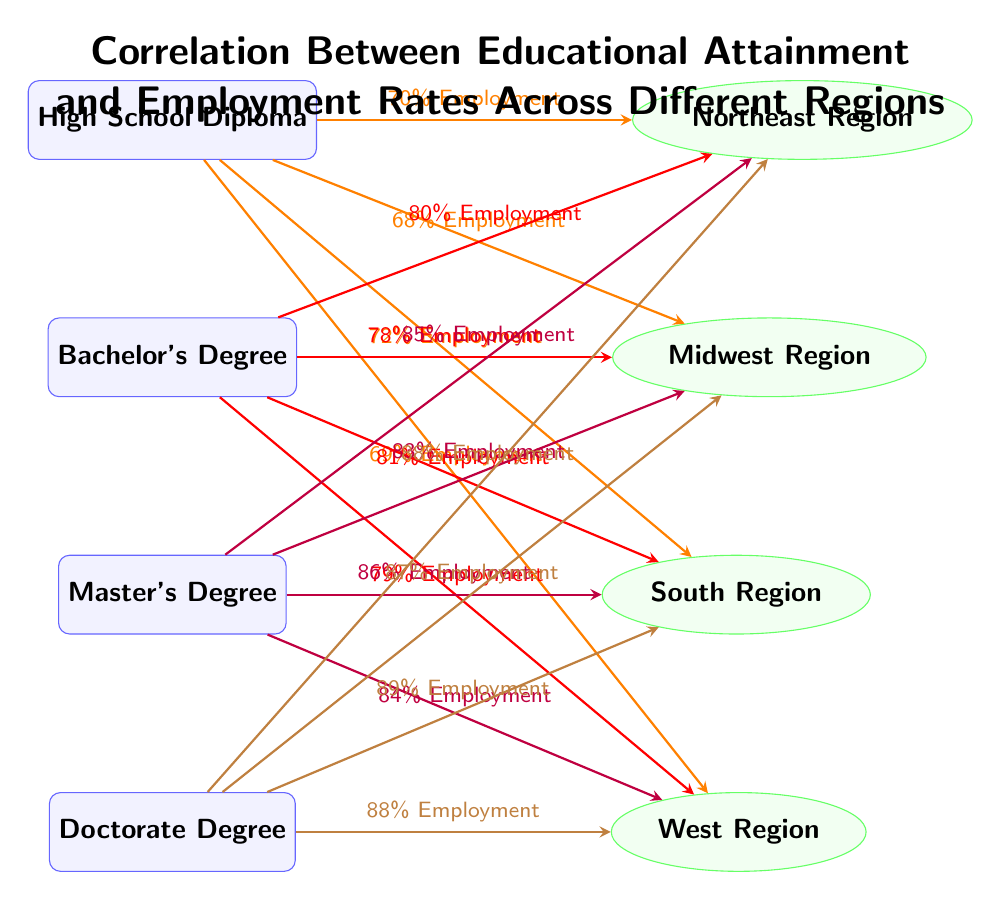What is the employment rate for Bachelor's Degree holders in the South Region? The diagram shows a connection between Bachelor's Degree and the South Region with an associated employment rate of 81%.
Answer: 81% How many education levels are represented in the diagram? The diagram includes four educational levels: High School Diploma, Bachelor's Degree, Master's Degree, and Doctorate Degree. Therefore, there are four education nodes in total.
Answer: 4 What is the employment rate for High School Diploma holders in the Midwest Region? The connection from the High School Diploma node to the Midwest Region indicates an employment rate of 68%.
Answer: 68% Which educational attainment has the highest employment rate in the Northeast Region? By comparing the employment rates for all education levels in the Northeast Region, the Doctorate Degree shows the highest employment rate at 88%.
Answer: Doctorate Degree How does employment rate change from High School Diploma to Master's Degree in the West Region? The employment rate for High School Diploma holders in the West Region is 69%, while for Master's Degree holders, it is 84%. Thus, there is an increase of 15%.
Answer: Increase by 15% Which region shows the highest employment rate for Master’s Degree holders? The diagram indicates that the employment rate for Master’s Degree holders is 85% in the Northeast Region, which is the highest compared to other regions.
Answer: Northeast Region What is the employment rate difference between High School Diploma and Doctorate Degree in the Midwest Region? The employment rate for High School Diploma holders in the Midwest Region is 68% and for Doctorate Degree holders, it is 87%. The difference between these two rates is 19%.
Answer: 19% Which educational level has a connection to the South Region? The diagram shows connections from High School Diploma, Bachelor's Degree, Master's Degree, and Doctorate Degree to the South Region, indicating all levels are represented.
Answer: All levels (4) What color represents the connections for Master's Degree in the diagram? The connections for Master's Degree are represented in purple color in the diagram.
Answer: Purple 